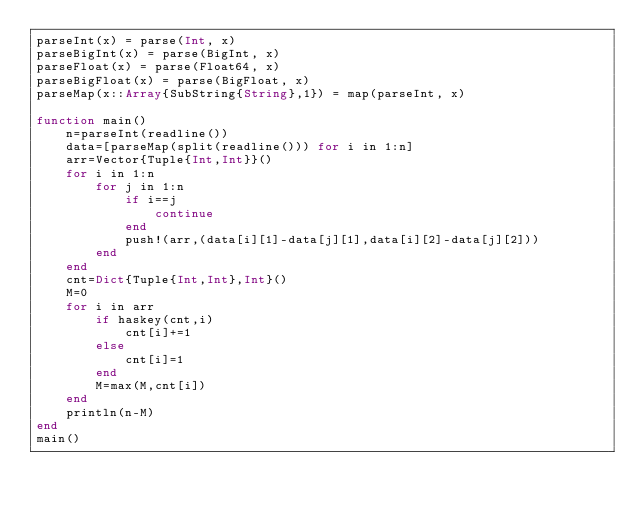Convert code to text. <code><loc_0><loc_0><loc_500><loc_500><_Julia_>parseInt(x) = parse(Int, x)
parseBigInt(x) = parse(BigInt, x)
parseFloat(x) = parse(Float64, x)
parseBigFloat(x) = parse(BigFloat, x)
parseMap(x::Array{SubString{String},1}) = map(parseInt, x)

function main()
    n=parseInt(readline())
    data=[parseMap(split(readline())) for i in 1:n]
    arr=Vector{Tuple{Int,Int}}()
    for i in 1:n
        for j in 1:n
            if i==j
                continue
            end
            push!(arr,(data[i][1]-data[j][1],data[i][2]-data[j][2]))
        end
    end
    cnt=Dict{Tuple{Int,Int},Int}()
    M=0
    for i in arr
        if haskey(cnt,i)
            cnt[i]+=1
        else
            cnt[i]=1
        end
        M=max(M,cnt[i])
    end
    println(n-M)
end
main()</code> 